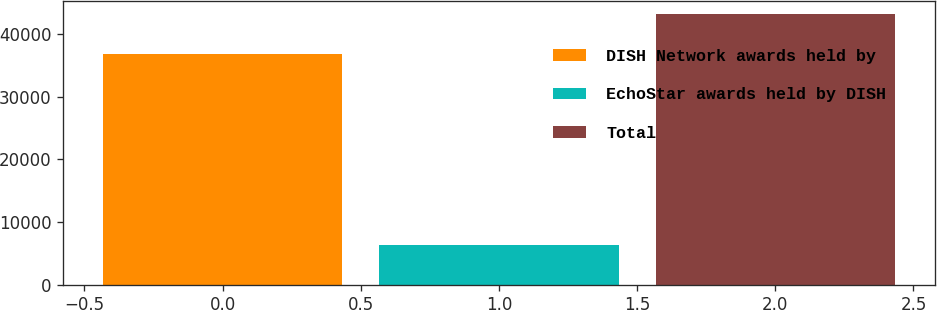Convert chart. <chart><loc_0><loc_0><loc_500><loc_500><bar_chart><fcel>DISH Network awards held by<fcel>EchoStar awards held by DISH<fcel>Total<nl><fcel>36840<fcel>6356<fcel>43196<nl></chart> 